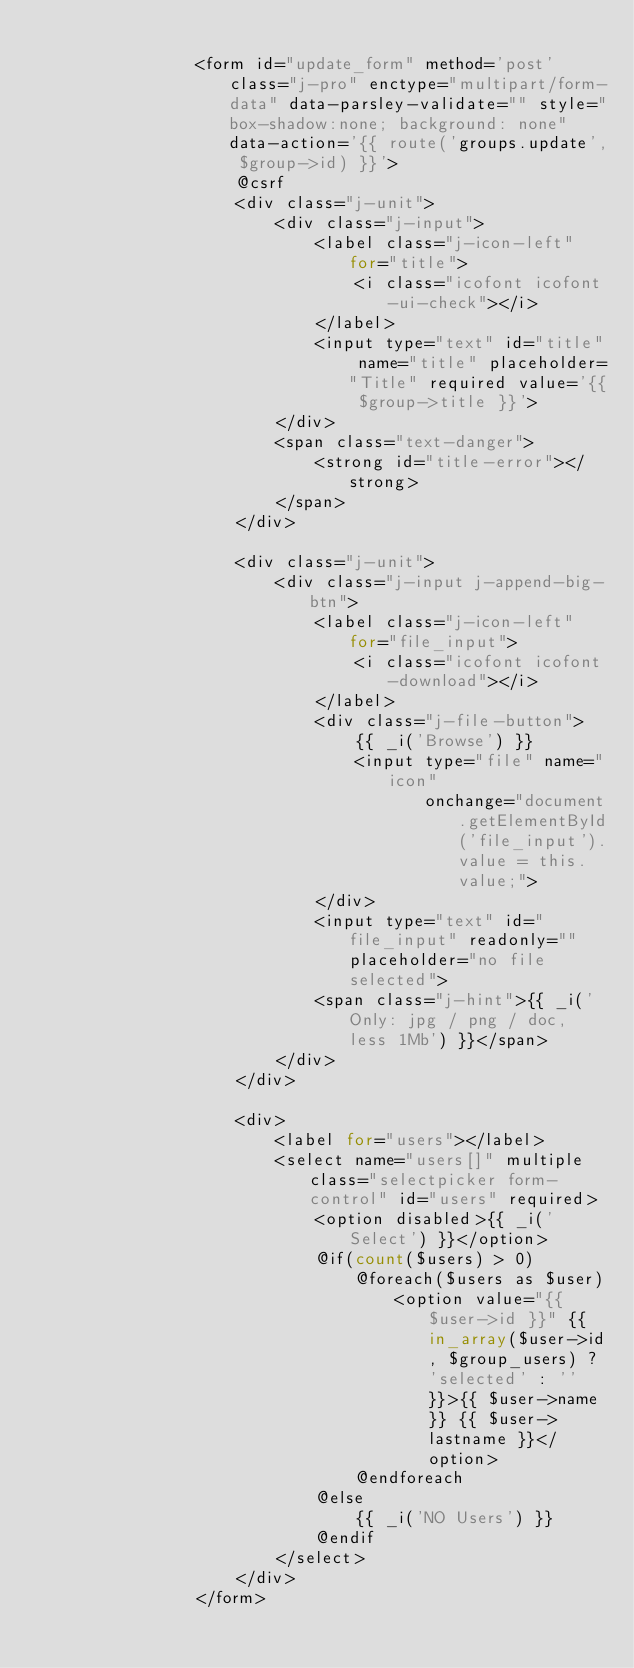<code> <loc_0><loc_0><loc_500><loc_500><_PHP_>
                <form id="update_form" method='post' class="j-pro" enctype="multipart/form-data" data-parsley-validate="" style="box-shadow:none; background: none" data-action='{{ route('groups.update', $group->id) }}'>
                    @csrf
                    <div class="j-unit">
                        <div class="j-input">
                            <label class="j-icon-left" for="title">
                                <i class="icofont icofont-ui-check"></i>
                            </label>
                            <input type="text" id="title" name="title" placeholder="Title" required value='{{ $group->title }}'>
                        </div>
                        <span class="text-danger">
                            <strong id="title-error"></strong>
                        </span>
                    </div>

                    <div class="j-unit">
                        <div class="j-input j-append-big-btn">
                            <label class="j-icon-left" for="file_input">
                                <i class="icofont icofont-download"></i>
                            </label>
                            <div class="j-file-button">
                                {{ _i('Browse') }}
                                <input type="file" name="icon"
                                       onchange="document.getElementById('file_input').value = this.value;">
                            </div>
                            <input type="text" id="file_input" readonly="" placeholder="no file selected">
                            <span class="j-hint">{{ _i('Only: jpg / png / doc, less 1Mb') }}</span>
                        </div>
                    </div>

                    <div>
                        <label for="users"></label>
                        <select name="users[]" multiple class="selectpicker form-control" id="users" required>
                            <option disabled>{{ _i('Select') }}</option>
                            @if(count($users) > 0)
                                @foreach($users as $user)
                                    <option value="{{ $user->id }}" {{ in_array($user->id, $group_users) ? 'selected' : '' }}>{{ $user->name }} {{ $user->lastname }}</option>
                                @endforeach
                            @else
                                {{ _i('NO Users') }}
                            @endif
                        </select>
                    </div>
                </form>
</code> 